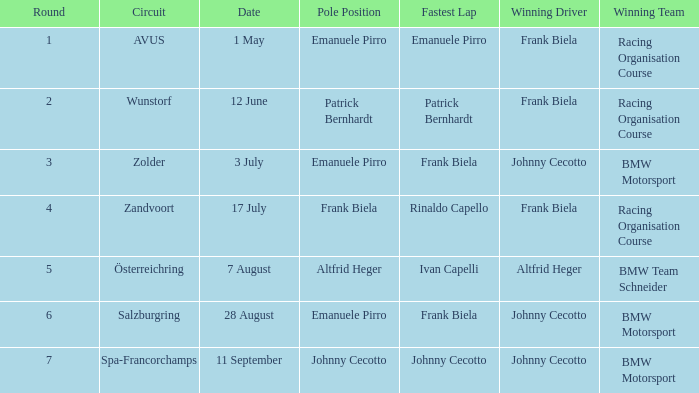Who had pole position in round 7? Johnny Cecotto. 